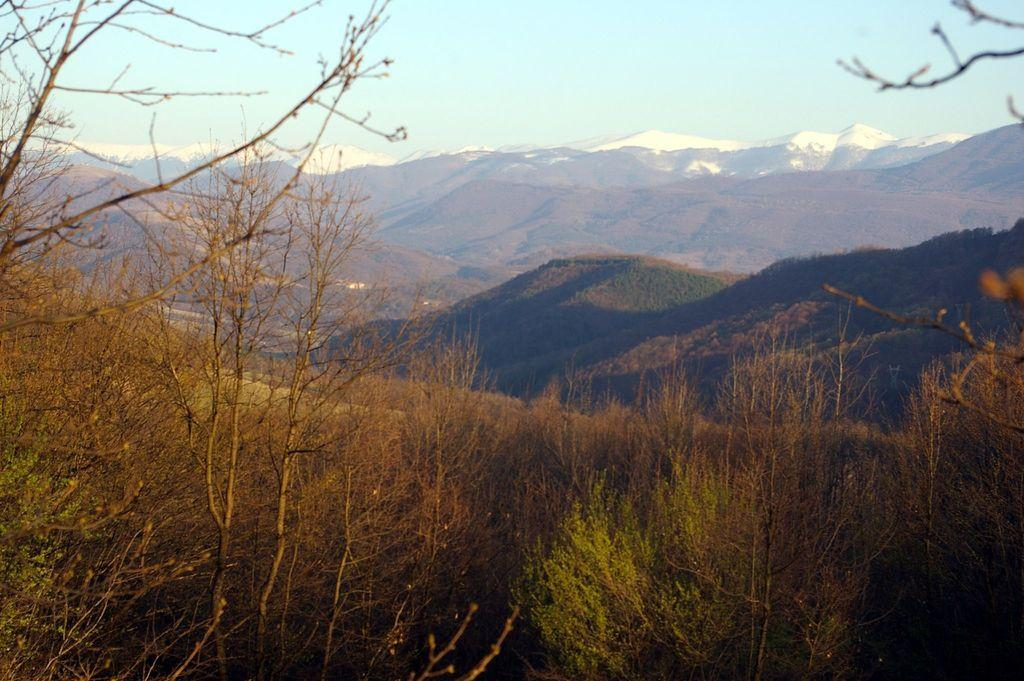What type of vegetation can be seen in the foreground of the image? There are plants in the foreground of the image. What type of terrain is visible in the foreground of the image? There is grassland in the foreground of the image. What type of geographical feature can be seen in the background of the image? There are mountains in the background of the image. What is visible in the background of the image besides the mountains? The sky is visible in the background of the image. What type of loaf is being used as a prop in the image? There is no loaf present in the image. What is the zinc content of the plants in the foreground? The provided facts do not mention the zinc content of the plants, and it cannot be determined from the image. 